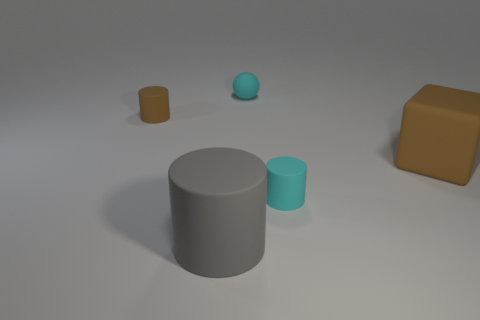How many other things are there of the same color as the matte block?
Offer a very short reply. 1. What number of spheres are either tiny objects or small cyan things?
Offer a very short reply. 1. There is a large thing that is in front of the big brown block; what is its shape?
Offer a terse response. Cylinder. How many brown cylinders have the same material as the gray cylinder?
Your answer should be very brief. 1. Is the number of cyan matte cylinders that are on the right side of the large gray object less than the number of brown rubber cubes?
Your answer should be compact. No. How big is the cyan object left of the cyan object that is in front of the small brown thing?
Provide a succinct answer. Small. Is the color of the cube the same as the tiny object on the left side of the cyan sphere?
Make the answer very short. Yes. Is the number of spheres behind the tiny cyan rubber ball less than the number of matte objects that are on the left side of the gray matte object?
Make the answer very short. Yes. There is a brown thing that is right of the cylinder behind the small cyan matte cylinder; what shape is it?
Provide a short and direct response. Cube. Are any tiny gray rubber blocks visible?
Provide a short and direct response. No. 